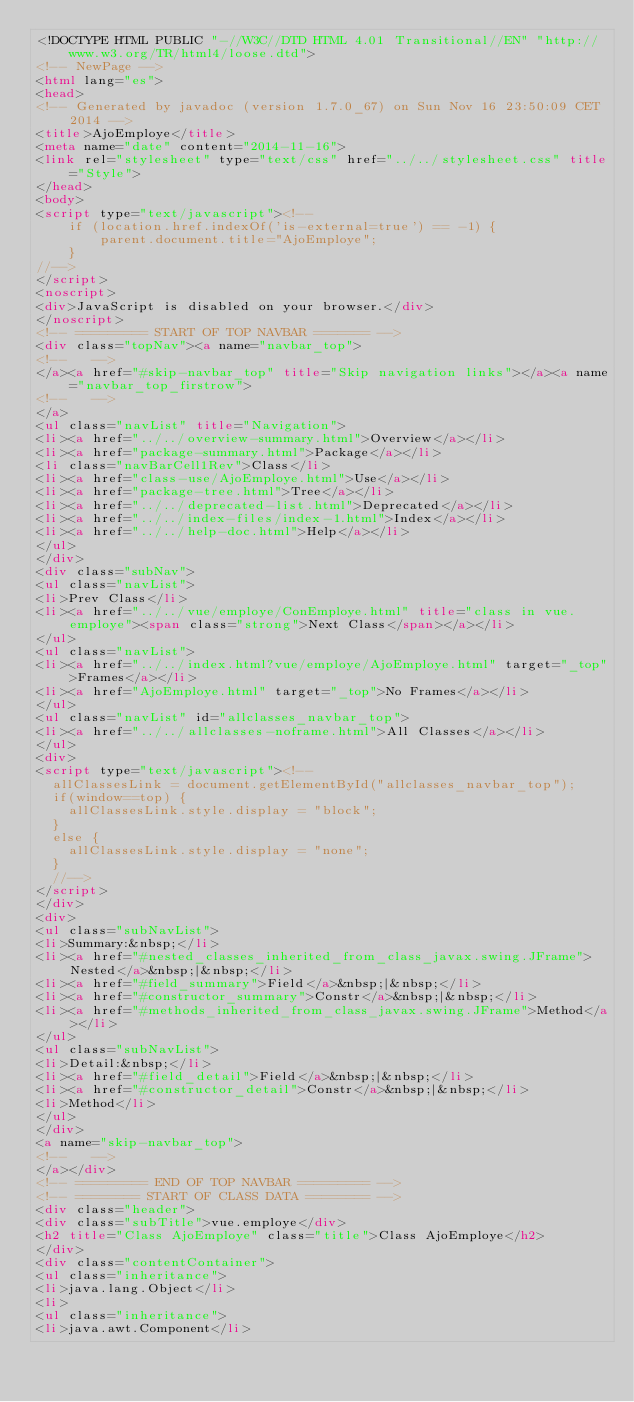<code> <loc_0><loc_0><loc_500><loc_500><_HTML_><!DOCTYPE HTML PUBLIC "-//W3C//DTD HTML 4.01 Transitional//EN" "http://www.w3.org/TR/html4/loose.dtd">
<!-- NewPage -->
<html lang="es">
<head>
<!-- Generated by javadoc (version 1.7.0_67) on Sun Nov 16 23:50:09 CET 2014 -->
<title>AjoEmploye</title>
<meta name="date" content="2014-11-16">
<link rel="stylesheet" type="text/css" href="../../stylesheet.css" title="Style">
</head>
<body>
<script type="text/javascript"><!--
    if (location.href.indexOf('is-external=true') == -1) {
        parent.document.title="AjoEmploye";
    }
//-->
</script>
<noscript>
<div>JavaScript is disabled on your browser.</div>
</noscript>
<!-- ========= START OF TOP NAVBAR ======= -->
<div class="topNav"><a name="navbar_top">
<!--   -->
</a><a href="#skip-navbar_top" title="Skip navigation links"></a><a name="navbar_top_firstrow">
<!--   -->
</a>
<ul class="navList" title="Navigation">
<li><a href="../../overview-summary.html">Overview</a></li>
<li><a href="package-summary.html">Package</a></li>
<li class="navBarCell1Rev">Class</li>
<li><a href="class-use/AjoEmploye.html">Use</a></li>
<li><a href="package-tree.html">Tree</a></li>
<li><a href="../../deprecated-list.html">Deprecated</a></li>
<li><a href="../../index-files/index-1.html">Index</a></li>
<li><a href="../../help-doc.html">Help</a></li>
</ul>
</div>
<div class="subNav">
<ul class="navList">
<li>Prev Class</li>
<li><a href="../../vue/employe/ConEmploye.html" title="class in vue.employe"><span class="strong">Next Class</span></a></li>
</ul>
<ul class="navList">
<li><a href="../../index.html?vue/employe/AjoEmploye.html" target="_top">Frames</a></li>
<li><a href="AjoEmploye.html" target="_top">No Frames</a></li>
</ul>
<ul class="navList" id="allclasses_navbar_top">
<li><a href="../../allclasses-noframe.html">All Classes</a></li>
</ul>
<div>
<script type="text/javascript"><!--
  allClassesLink = document.getElementById("allclasses_navbar_top");
  if(window==top) {
    allClassesLink.style.display = "block";
  }
  else {
    allClassesLink.style.display = "none";
  }
  //-->
</script>
</div>
<div>
<ul class="subNavList">
<li>Summary:&nbsp;</li>
<li><a href="#nested_classes_inherited_from_class_javax.swing.JFrame">Nested</a>&nbsp;|&nbsp;</li>
<li><a href="#field_summary">Field</a>&nbsp;|&nbsp;</li>
<li><a href="#constructor_summary">Constr</a>&nbsp;|&nbsp;</li>
<li><a href="#methods_inherited_from_class_javax.swing.JFrame">Method</a></li>
</ul>
<ul class="subNavList">
<li>Detail:&nbsp;</li>
<li><a href="#field_detail">Field</a>&nbsp;|&nbsp;</li>
<li><a href="#constructor_detail">Constr</a>&nbsp;|&nbsp;</li>
<li>Method</li>
</ul>
</div>
<a name="skip-navbar_top">
<!--   -->
</a></div>
<!-- ========= END OF TOP NAVBAR ========= -->
<!-- ======== START OF CLASS DATA ======== -->
<div class="header">
<div class="subTitle">vue.employe</div>
<h2 title="Class AjoEmploye" class="title">Class AjoEmploye</h2>
</div>
<div class="contentContainer">
<ul class="inheritance">
<li>java.lang.Object</li>
<li>
<ul class="inheritance">
<li>java.awt.Component</li></code> 